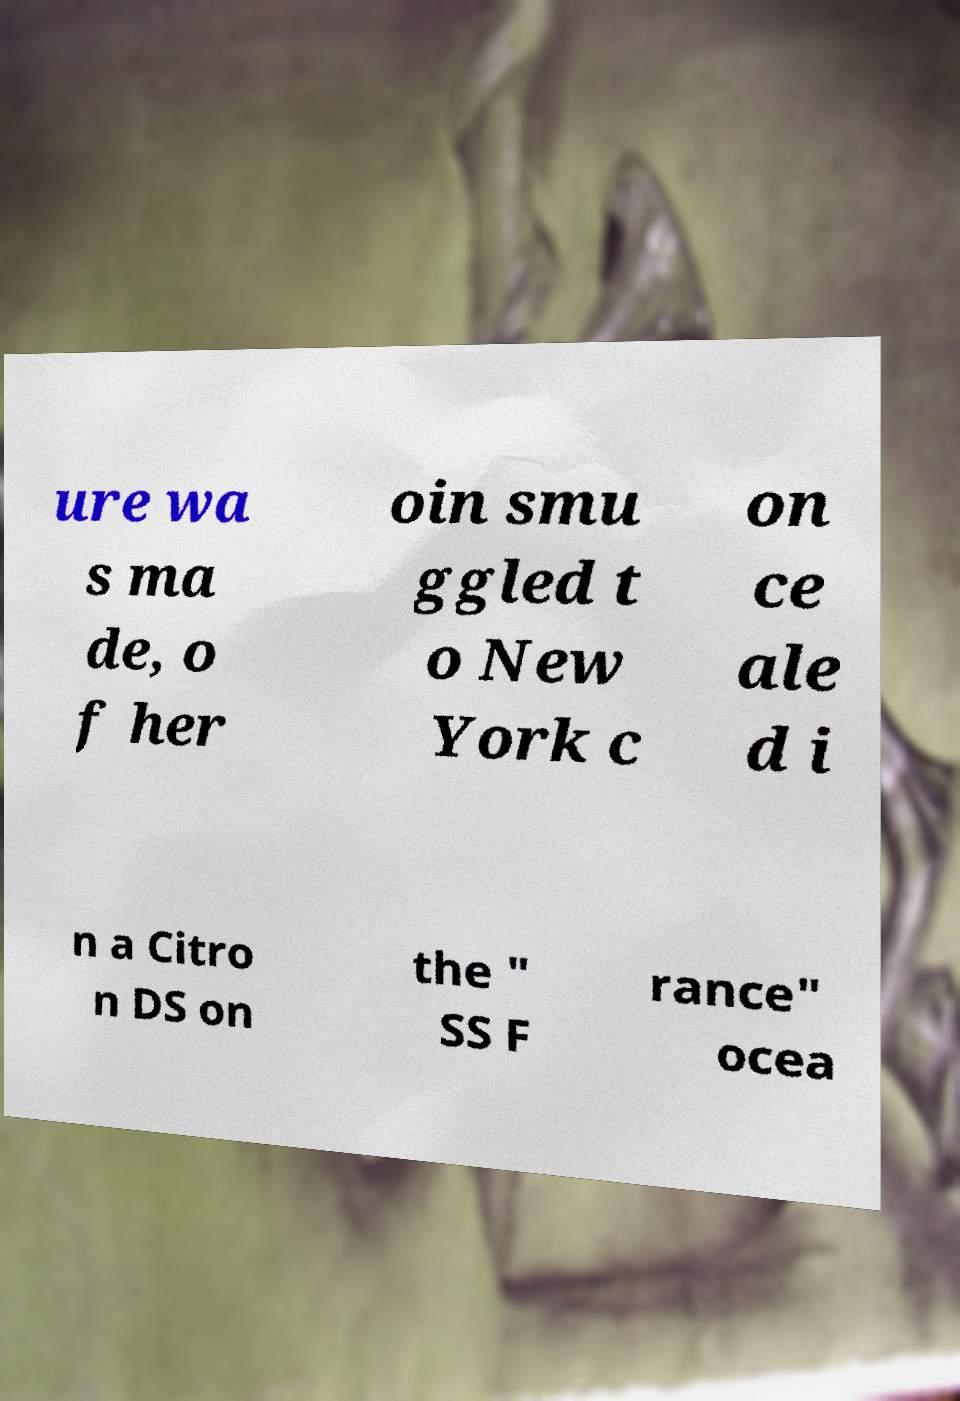Please read and relay the text visible in this image. What does it say? ure wa s ma de, o f her oin smu ggled t o New York c on ce ale d i n a Citro n DS on the " SS F rance" ocea 